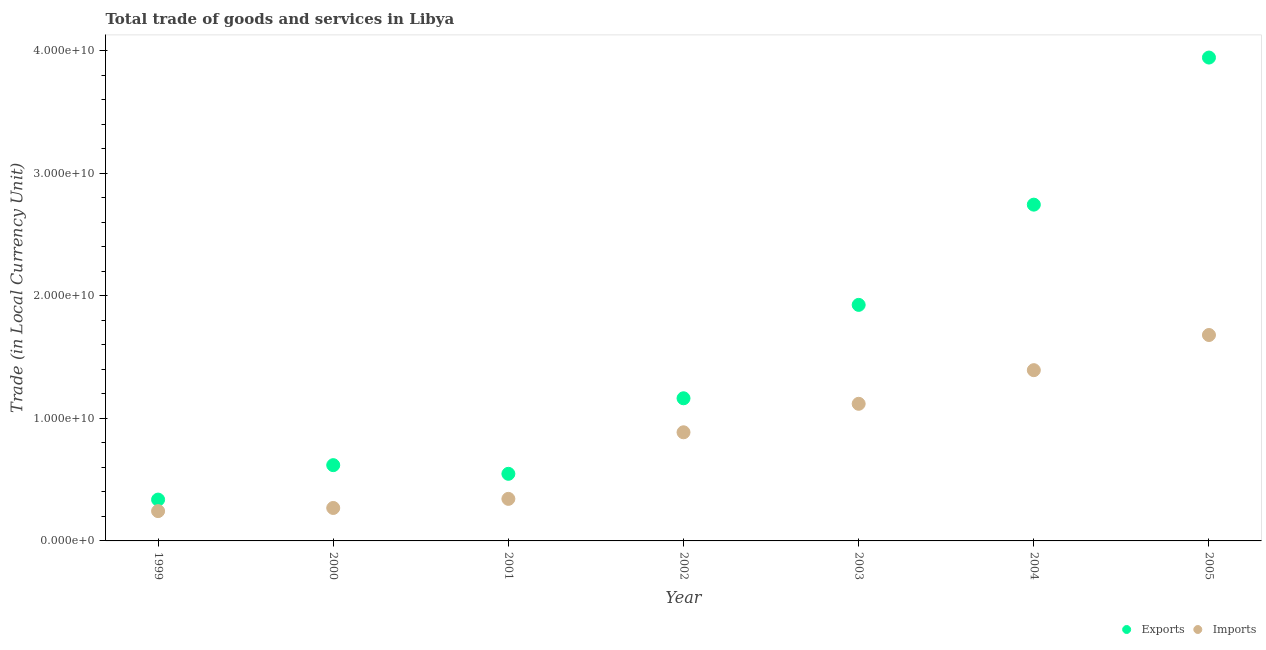What is the imports of goods and services in 2005?
Make the answer very short. 1.68e+1. Across all years, what is the maximum imports of goods and services?
Your answer should be compact. 1.68e+1. Across all years, what is the minimum imports of goods and services?
Keep it short and to the point. 2.43e+09. In which year was the export of goods and services maximum?
Provide a succinct answer. 2005. What is the total imports of goods and services in the graph?
Make the answer very short. 5.94e+1. What is the difference between the export of goods and services in 1999 and that in 2002?
Your answer should be very brief. -8.27e+09. What is the difference between the imports of goods and services in 2003 and the export of goods and services in 2002?
Your answer should be very brief. -4.51e+08. What is the average imports of goods and services per year?
Offer a very short reply. 8.48e+09. In the year 2003, what is the difference between the imports of goods and services and export of goods and services?
Ensure brevity in your answer.  -8.08e+09. What is the ratio of the export of goods and services in 1999 to that in 2004?
Keep it short and to the point. 0.12. Is the imports of goods and services in 2000 less than that in 2002?
Make the answer very short. Yes. Is the difference between the export of goods and services in 1999 and 2001 greater than the difference between the imports of goods and services in 1999 and 2001?
Your answer should be very brief. No. What is the difference between the highest and the second highest export of goods and services?
Keep it short and to the point. 1.20e+1. What is the difference between the highest and the lowest imports of goods and services?
Keep it short and to the point. 1.44e+1. In how many years, is the imports of goods and services greater than the average imports of goods and services taken over all years?
Make the answer very short. 4. Is the sum of the imports of goods and services in 2001 and 2003 greater than the maximum export of goods and services across all years?
Give a very brief answer. No. Is the export of goods and services strictly less than the imports of goods and services over the years?
Keep it short and to the point. No. How many dotlines are there?
Offer a terse response. 2. What is the difference between two consecutive major ticks on the Y-axis?
Provide a short and direct response. 1.00e+1. Does the graph contain any zero values?
Your answer should be very brief. No. Does the graph contain grids?
Your response must be concise. No. Where does the legend appear in the graph?
Offer a very short reply. Bottom right. What is the title of the graph?
Provide a succinct answer. Total trade of goods and services in Libya. What is the label or title of the X-axis?
Give a very brief answer. Year. What is the label or title of the Y-axis?
Offer a terse response. Trade (in Local Currency Unit). What is the Trade (in Local Currency Unit) of Exports in 1999?
Provide a short and direct response. 3.37e+09. What is the Trade (in Local Currency Unit) in Imports in 1999?
Provide a succinct answer. 2.43e+09. What is the Trade (in Local Currency Unit) of Exports in 2000?
Your response must be concise. 6.19e+09. What is the Trade (in Local Currency Unit) of Imports in 2000?
Your answer should be compact. 2.69e+09. What is the Trade (in Local Currency Unit) of Exports in 2001?
Keep it short and to the point. 5.48e+09. What is the Trade (in Local Currency Unit) of Imports in 2001?
Your response must be concise. 3.43e+09. What is the Trade (in Local Currency Unit) in Exports in 2002?
Provide a succinct answer. 1.16e+1. What is the Trade (in Local Currency Unit) in Imports in 2002?
Provide a succinct answer. 8.87e+09. What is the Trade (in Local Currency Unit) of Exports in 2003?
Your answer should be compact. 1.93e+1. What is the Trade (in Local Currency Unit) in Imports in 2003?
Ensure brevity in your answer.  1.12e+1. What is the Trade (in Local Currency Unit) of Exports in 2004?
Offer a terse response. 2.75e+1. What is the Trade (in Local Currency Unit) in Imports in 2004?
Give a very brief answer. 1.39e+1. What is the Trade (in Local Currency Unit) of Exports in 2005?
Give a very brief answer. 3.95e+1. What is the Trade (in Local Currency Unit) in Imports in 2005?
Your response must be concise. 1.68e+1. Across all years, what is the maximum Trade (in Local Currency Unit) in Exports?
Provide a short and direct response. 3.95e+1. Across all years, what is the maximum Trade (in Local Currency Unit) of Imports?
Your answer should be compact. 1.68e+1. Across all years, what is the minimum Trade (in Local Currency Unit) of Exports?
Offer a terse response. 3.37e+09. Across all years, what is the minimum Trade (in Local Currency Unit) in Imports?
Ensure brevity in your answer.  2.43e+09. What is the total Trade (in Local Currency Unit) of Exports in the graph?
Offer a very short reply. 1.13e+11. What is the total Trade (in Local Currency Unit) in Imports in the graph?
Keep it short and to the point. 5.94e+1. What is the difference between the Trade (in Local Currency Unit) in Exports in 1999 and that in 2000?
Ensure brevity in your answer.  -2.81e+09. What is the difference between the Trade (in Local Currency Unit) in Imports in 1999 and that in 2000?
Give a very brief answer. -2.57e+08. What is the difference between the Trade (in Local Currency Unit) in Exports in 1999 and that in 2001?
Give a very brief answer. -2.10e+09. What is the difference between the Trade (in Local Currency Unit) in Imports in 1999 and that in 2001?
Provide a succinct answer. -1.00e+09. What is the difference between the Trade (in Local Currency Unit) in Exports in 1999 and that in 2002?
Provide a succinct answer. -8.27e+09. What is the difference between the Trade (in Local Currency Unit) in Imports in 1999 and that in 2002?
Your response must be concise. -6.44e+09. What is the difference between the Trade (in Local Currency Unit) in Exports in 1999 and that in 2003?
Your answer should be very brief. -1.59e+1. What is the difference between the Trade (in Local Currency Unit) of Imports in 1999 and that in 2003?
Your answer should be compact. -8.76e+09. What is the difference between the Trade (in Local Currency Unit) of Exports in 1999 and that in 2004?
Your response must be concise. -2.41e+1. What is the difference between the Trade (in Local Currency Unit) of Imports in 1999 and that in 2004?
Provide a succinct answer. -1.15e+1. What is the difference between the Trade (in Local Currency Unit) in Exports in 1999 and that in 2005?
Offer a terse response. -3.61e+1. What is the difference between the Trade (in Local Currency Unit) of Imports in 1999 and that in 2005?
Your answer should be very brief. -1.44e+1. What is the difference between the Trade (in Local Currency Unit) in Exports in 2000 and that in 2001?
Your answer should be compact. 7.08e+08. What is the difference between the Trade (in Local Currency Unit) in Imports in 2000 and that in 2001?
Give a very brief answer. -7.43e+08. What is the difference between the Trade (in Local Currency Unit) of Exports in 2000 and that in 2002?
Offer a terse response. -5.46e+09. What is the difference between the Trade (in Local Currency Unit) of Imports in 2000 and that in 2002?
Provide a succinct answer. -6.18e+09. What is the difference between the Trade (in Local Currency Unit) of Exports in 2000 and that in 2003?
Provide a short and direct response. -1.31e+1. What is the difference between the Trade (in Local Currency Unit) of Imports in 2000 and that in 2003?
Offer a very short reply. -8.50e+09. What is the difference between the Trade (in Local Currency Unit) of Exports in 2000 and that in 2004?
Make the answer very short. -2.13e+1. What is the difference between the Trade (in Local Currency Unit) in Imports in 2000 and that in 2004?
Offer a very short reply. -1.12e+1. What is the difference between the Trade (in Local Currency Unit) in Exports in 2000 and that in 2005?
Give a very brief answer. -3.33e+1. What is the difference between the Trade (in Local Currency Unit) of Imports in 2000 and that in 2005?
Provide a short and direct response. -1.41e+1. What is the difference between the Trade (in Local Currency Unit) of Exports in 2001 and that in 2002?
Give a very brief answer. -6.17e+09. What is the difference between the Trade (in Local Currency Unit) in Imports in 2001 and that in 2002?
Offer a very short reply. -5.44e+09. What is the difference between the Trade (in Local Currency Unit) in Exports in 2001 and that in 2003?
Provide a succinct answer. -1.38e+1. What is the difference between the Trade (in Local Currency Unit) in Imports in 2001 and that in 2003?
Give a very brief answer. -7.76e+09. What is the difference between the Trade (in Local Currency Unit) of Exports in 2001 and that in 2004?
Your response must be concise. -2.20e+1. What is the difference between the Trade (in Local Currency Unit) in Imports in 2001 and that in 2004?
Keep it short and to the point. -1.05e+1. What is the difference between the Trade (in Local Currency Unit) of Exports in 2001 and that in 2005?
Offer a terse response. -3.40e+1. What is the difference between the Trade (in Local Currency Unit) of Imports in 2001 and that in 2005?
Your answer should be very brief. -1.34e+1. What is the difference between the Trade (in Local Currency Unit) in Exports in 2002 and that in 2003?
Your answer should be very brief. -7.62e+09. What is the difference between the Trade (in Local Currency Unit) of Imports in 2002 and that in 2003?
Provide a short and direct response. -2.33e+09. What is the difference between the Trade (in Local Currency Unit) of Exports in 2002 and that in 2004?
Provide a succinct answer. -1.58e+1. What is the difference between the Trade (in Local Currency Unit) in Imports in 2002 and that in 2004?
Give a very brief answer. -5.07e+09. What is the difference between the Trade (in Local Currency Unit) in Exports in 2002 and that in 2005?
Provide a succinct answer. -2.78e+1. What is the difference between the Trade (in Local Currency Unit) in Imports in 2002 and that in 2005?
Offer a terse response. -7.94e+09. What is the difference between the Trade (in Local Currency Unit) in Exports in 2003 and that in 2004?
Give a very brief answer. -8.18e+09. What is the difference between the Trade (in Local Currency Unit) in Imports in 2003 and that in 2004?
Your response must be concise. -2.75e+09. What is the difference between the Trade (in Local Currency Unit) in Exports in 2003 and that in 2005?
Give a very brief answer. -2.02e+1. What is the difference between the Trade (in Local Currency Unit) in Imports in 2003 and that in 2005?
Make the answer very short. -5.62e+09. What is the difference between the Trade (in Local Currency Unit) in Exports in 2004 and that in 2005?
Offer a very short reply. -1.20e+1. What is the difference between the Trade (in Local Currency Unit) in Imports in 2004 and that in 2005?
Your answer should be very brief. -2.87e+09. What is the difference between the Trade (in Local Currency Unit) in Exports in 1999 and the Trade (in Local Currency Unit) in Imports in 2000?
Keep it short and to the point. 6.84e+08. What is the difference between the Trade (in Local Currency Unit) in Exports in 1999 and the Trade (in Local Currency Unit) in Imports in 2001?
Ensure brevity in your answer.  -5.90e+07. What is the difference between the Trade (in Local Currency Unit) in Exports in 1999 and the Trade (in Local Currency Unit) in Imports in 2002?
Keep it short and to the point. -5.49e+09. What is the difference between the Trade (in Local Currency Unit) in Exports in 1999 and the Trade (in Local Currency Unit) in Imports in 2003?
Give a very brief answer. -7.82e+09. What is the difference between the Trade (in Local Currency Unit) of Exports in 1999 and the Trade (in Local Currency Unit) of Imports in 2004?
Your answer should be compact. -1.06e+1. What is the difference between the Trade (in Local Currency Unit) of Exports in 1999 and the Trade (in Local Currency Unit) of Imports in 2005?
Keep it short and to the point. -1.34e+1. What is the difference between the Trade (in Local Currency Unit) of Exports in 2000 and the Trade (in Local Currency Unit) of Imports in 2001?
Your answer should be compact. 2.75e+09. What is the difference between the Trade (in Local Currency Unit) of Exports in 2000 and the Trade (in Local Currency Unit) of Imports in 2002?
Your answer should be compact. -2.68e+09. What is the difference between the Trade (in Local Currency Unit) of Exports in 2000 and the Trade (in Local Currency Unit) of Imports in 2003?
Give a very brief answer. -5.01e+09. What is the difference between the Trade (in Local Currency Unit) of Exports in 2000 and the Trade (in Local Currency Unit) of Imports in 2004?
Give a very brief answer. -7.75e+09. What is the difference between the Trade (in Local Currency Unit) of Exports in 2000 and the Trade (in Local Currency Unit) of Imports in 2005?
Your answer should be very brief. -1.06e+1. What is the difference between the Trade (in Local Currency Unit) in Exports in 2001 and the Trade (in Local Currency Unit) in Imports in 2002?
Your answer should be compact. -3.39e+09. What is the difference between the Trade (in Local Currency Unit) in Exports in 2001 and the Trade (in Local Currency Unit) in Imports in 2003?
Give a very brief answer. -5.72e+09. What is the difference between the Trade (in Local Currency Unit) in Exports in 2001 and the Trade (in Local Currency Unit) in Imports in 2004?
Offer a terse response. -8.46e+09. What is the difference between the Trade (in Local Currency Unit) of Exports in 2001 and the Trade (in Local Currency Unit) of Imports in 2005?
Ensure brevity in your answer.  -1.13e+1. What is the difference between the Trade (in Local Currency Unit) in Exports in 2002 and the Trade (in Local Currency Unit) in Imports in 2003?
Your answer should be very brief. 4.51e+08. What is the difference between the Trade (in Local Currency Unit) in Exports in 2002 and the Trade (in Local Currency Unit) in Imports in 2004?
Provide a short and direct response. -2.29e+09. What is the difference between the Trade (in Local Currency Unit) in Exports in 2002 and the Trade (in Local Currency Unit) in Imports in 2005?
Keep it short and to the point. -5.17e+09. What is the difference between the Trade (in Local Currency Unit) of Exports in 2003 and the Trade (in Local Currency Unit) of Imports in 2004?
Your answer should be very brief. 5.33e+09. What is the difference between the Trade (in Local Currency Unit) in Exports in 2003 and the Trade (in Local Currency Unit) in Imports in 2005?
Provide a short and direct response. 2.46e+09. What is the difference between the Trade (in Local Currency Unit) in Exports in 2004 and the Trade (in Local Currency Unit) in Imports in 2005?
Offer a very short reply. 1.06e+1. What is the average Trade (in Local Currency Unit) in Exports per year?
Offer a terse response. 1.61e+1. What is the average Trade (in Local Currency Unit) in Imports per year?
Offer a very short reply. 8.48e+09. In the year 1999, what is the difference between the Trade (in Local Currency Unit) of Exports and Trade (in Local Currency Unit) of Imports?
Offer a terse response. 9.41e+08. In the year 2000, what is the difference between the Trade (in Local Currency Unit) of Exports and Trade (in Local Currency Unit) of Imports?
Your answer should be very brief. 3.50e+09. In the year 2001, what is the difference between the Trade (in Local Currency Unit) in Exports and Trade (in Local Currency Unit) in Imports?
Your answer should be very brief. 2.04e+09. In the year 2002, what is the difference between the Trade (in Local Currency Unit) of Exports and Trade (in Local Currency Unit) of Imports?
Offer a very short reply. 2.78e+09. In the year 2003, what is the difference between the Trade (in Local Currency Unit) of Exports and Trade (in Local Currency Unit) of Imports?
Make the answer very short. 8.08e+09. In the year 2004, what is the difference between the Trade (in Local Currency Unit) in Exports and Trade (in Local Currency Unit) in Imports?
Your answer should be very brief. 1.35e+1. In the year 2005, what is the difference between the Trade (in Local Currency Unit) in Exports and Trade (in Local Currency Unit) in Imports?
Give a very brief answer. 2.27e+1. What is the ratio of the Trade (in Local Currency Unit) of Exports in 1999 to that in 2000?
Make the answer very short. 0.55. What is the ratio of the Trade (in Local Currency Unit) of Imports in 1999 to that in 2000?
Provide a succinct answer. 0.9. What is the ratio of the Trade (in Local Currency Unit) of Exports in 1999 to that in 2001?
Your response must be concise. 0.62. What is the ratio of the Trade (in Local Currency Unit) of Imports in 1999 to that in 2001?
Make the answer very short. 0.71. What is the ratio of the Trade (in Local Currency Unit) of Exports in 1999 to that in 2002?
Your answer should be compact. 0.29. What is the ratio of the Trade (in Local Currency Unit) in Imports in 1999 to that in 2002?
Keep it short and to the point. 0.27. What is the ratio of the Trade (in Local Currency Unit) in Exports in 1999 to that in 2003?
Keep it short and to the point. 0.18. What is the ratio of the Trade (in Local Currency Unit) in Imports in 1999 to that in 2003?
Offer a very short reply. 0.22. What is the ratio of the Trade (in Local Currency Unit) in Exports in 1999 to that in 2004?
Offer a very short reply. 0.12. What is the ratio of the Trade (in Local Currency Unit) of Imports in 1999 to that in 2004?
Make the answer very short. 0.17. What is the ratio of the Trade (in Local Currency Unit) in Exports in 1999 to that in 2005?
Ensure brevity in your answer.  0.09. What is the ratio of the Trade (in Local Currency Unit) in Imports in 1999 to that in 2005?
Provide a succinct answer. 0.14. What is the ratio of the Trade (in Local Currency Unit) in Exports in 2000 to that in 2001?
Offer a very short reply. 1.13. What is the ratio of the Trade (in Local Currency Unit) of Imports in 2000 to that in 2001?
Ensure brevity in your answer.  0.78. What is the ratio of the Trade (in Local Currency Unit) in Exports in 2000 to that in 2002?
Your answer should be very brief. 0.53. What is the ratio of the Trade (in Local Currency Unit) of Imports in 2000 to that in 2002?
Your answer should be compact. 0.3. What is the ratio of the Trade (in Local Currency Unit) of Exports in 2000 to that in 2003?
Ensure brevity in your answer.  0.32. What is the ratio of the Trade (in Local Currency Unit) of Imports in 2000 to that in 2003?
Make the answer very short. 0.24. What is the ratio of the Trade (in Local Currency Unit) in Exports in 2000 to that in 2004?
Keep it short and to the point. 0.23. What is the ratio of the Trade (in Local Currency Unit) of Imports in 2000 to that in 2004?
Make the answer very short. 0.19. What is the ratio of the Trade (in Local Currency Unit) in Exports in 2000 to that in 2005?
Give a very brief answer. 0.16. What is the ratio of the Trade (in Local Currency Unit) of Imports in 2000 to that in 2005?
Your answer should be compact. 0.16. What is the ratio of the Trade (in Local Currency Unit) of Exports in 2001 to that in 2002?
Your answer should be very brief. 0.47. What is the ratio of the Trade (in Local Currency Unit) of Imports in 2001 to that in 2002?
Ensure brevity in your answer.  0.39. What is the ratio of the Trade (in Local Currency Unit) of Exports in 2001 to that in 2003?
Give a very brief answer. 0.28. What is the ratio of the Trade (in Local Currency Unit) of Imports in 2001 to that in 2003?
Your answer should be very brief. 0.31. What is the ratio of the Trade (in Local Currency Unit) of Exports in 2001 to that in 2004?
Offer a very short reply. 0.2. What is the ratio of the Trade (in Local Currency Unit) of Imports in 2001 to that in 2004?
Offer a terse response. 0.25. What is the ratio of the Trade (in Local Currency Unit) of Exports in 2001 to that in 2005?
Give a very brief answer. 0.14. What is the ratio of the Trade (in Local Currency Unit) of Imports in 2001 to that in 2005?
Offer a terse response. 0.2. What is the ratio of the Trade (in Local Currency Unit) in Exports in 2002 to that in 2003?
Keep it short and to the point. 0.6. What is the ratio of the Trade (in Local Currency Unit) of Imports in 2002 to that in 2003?
Your answer should be very brief. 0.79. What is the ratio of the Trade (in Local Currency Unit) in Exports in 2002 to that in 2004?
Provide a short and direct response. 0.42. What is the ratio of the Trade (in Local Currency Unit) in Imports in 2002 to that in 2004?
Provide a short and direct response. 0.64. What is the ratio of the Trade (in Local Currency Unit) in Exports in 2002 to that in 2005?
Your answer should be compact. 0.3. What is the ratio of the Trade (in Local Currency Unit) in Imports in 2002 to that in 2005?
Your answer should be compact. 0.53. What is the ratio of the Trade (in Local Currency Unit) of Exports in 2003 to that in 2004?
Offer a very short reply. 0.7. What is the ratio of the Trade (in Local Currency Unit) of Imports in 2003 to that in 2004?
Provide a short and direct response. 0.8. What is the ratio of the Trade (in Local Currency Unit) in Exports in 2003 to that in 2005?
Provide a succinct answer. 0.49. What is the ratio of the Trade (in Local Currency Unit) in Imports in 2003 to that in 2005?
Give a very brief answer. 0.67. What is the ratio of the Trade (in Local Currency Unit) in Exports in 2004 to that in 2005?
Give a very brief answer. 0.7. What is the ratio of the Trade (in Local Currency Unit) of Imports in 2004 to that in 2005?
Offer a very short reply. 0.83. What is the difference between the highest and the second highest Trade (in Local Currency Unit) in Exports?
Your response must be concise. 1.20e+1. What is the difference between the highest and the second highest Trade (in Local Currency Unit) of Imports?
Keep it short and to the point. 2.87e+09. What is the difference between the highest and the lowest Trade (in Local Currency Unit) in Exports?
Give a very brief answer. 3.61e+1. What is the difference between the highest and the lowest Trade (in Local Currency Unit) of Imports?
Your answer should be very brief. 1.44e+1. 